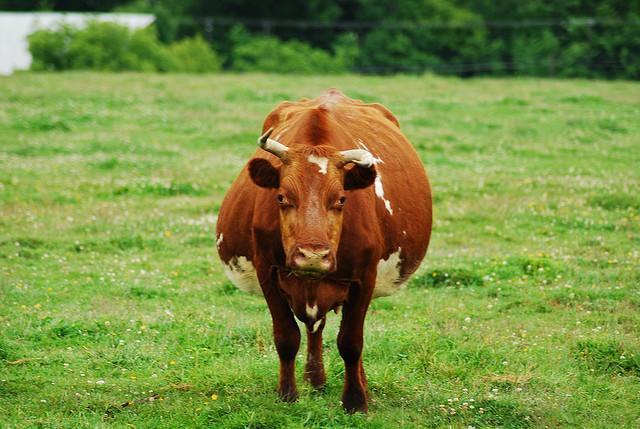How many boys are looking at their cell phones?
Give a very brief answer. 0. 